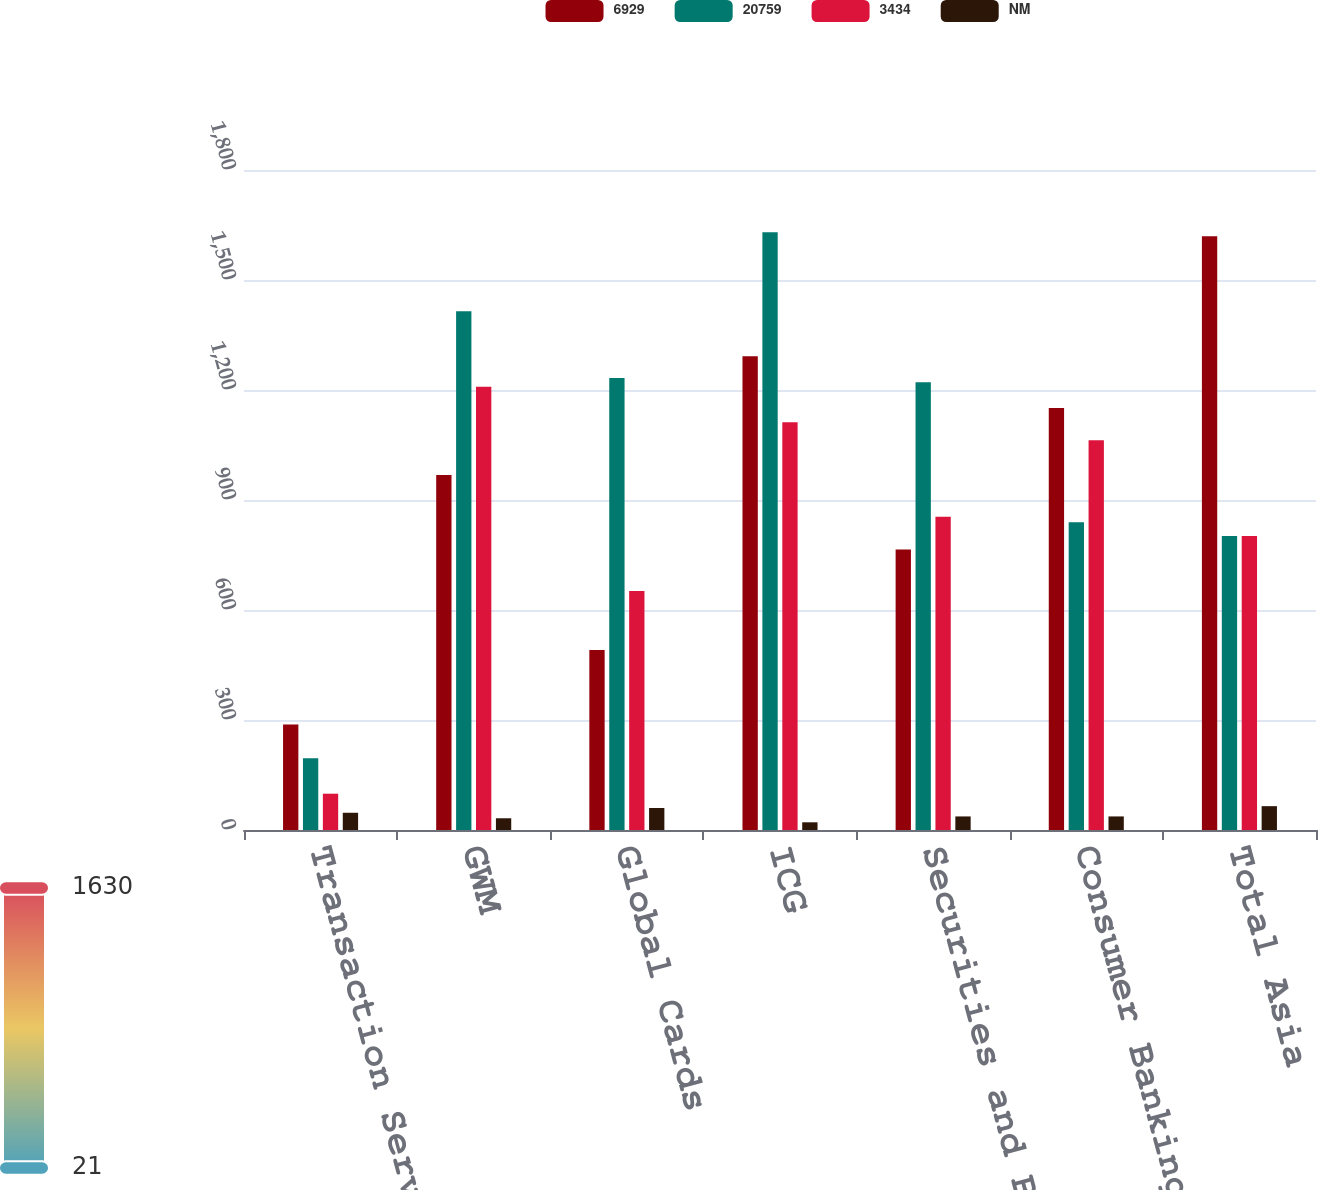Convert chart. <chart><loc_0><loc_0><loc_500><loc_500><stacked_bar_chart><ecel><fcel>Transaction Services<fcel>GWM<fcel>Global Cards<fcel>ICG<fcel>Securities and Banking<fcel>Consumer Banking<fcel>Total Asia<nl><fcel>6929<fcel>288<fcel>968<fcel>491<fcel>1292<fcel>765<fcel>1151<fcel>1619<nl><fcel>20759<fcel>196<fcel>1415<fcel>1233<fcel>1630<fcel>1221<fcel>839<fcel>802<nl><fcel>3434<fcel>99<fcel>1209<fcel>652<fcel>1112<fcel>854<fcel>1063<fcel>802<nl><fcel>NM<fcel>47<fcel>32<fcel>60<fcel>21<fcel>37<fcel>37<fcel>65<nl></chart> 